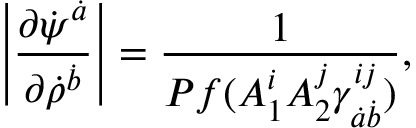Convert formula to latex. <formula><loc_0><loc_0><loc_500><loc_500>\left | { \frac { \partial \dot { \psi } ^ { \dot { a } } } { \partial \dot { \rho } ^ { \dot { b } } } } \right | = { \frac { 1 } { P f ( A _ { 1 } ^ { i } A _ { 2 } ^ { j } \gamma _ { \dot { a } \dot { b } } ^ { i j } ) } } ,</formula> 